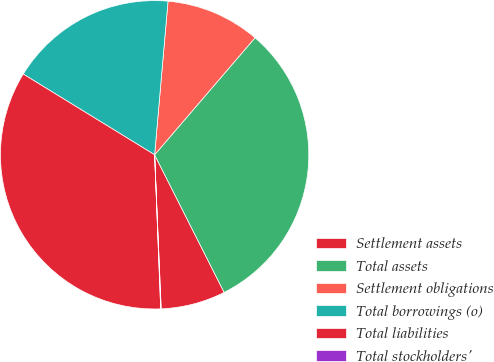<chart> <loc_0><loc_0><loc_500><loc_500><pie_chart><fcel>Settlement assets<fcel>Total assets<fcel>Settlement obligations<fcel>Total borrowings (o)<fcel>Total liabilities<fcel>Total stockholders'<nl><fcel>6.77%<fcel>31.27%<fcel>9.9%<fcel>17.62%<fcel>34.4%<fcel>0.05%<nl></chart> 